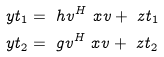Convert formula to latex. <formula><loc_0><loc_0><loc_500><loc_500>\ y t _ { 1 } & = \ h v ^ { H } \ x v + \ z t _ { 1 } \\ \ y t _ { 2 } & = \ g v ^ { H } \ x v + \ z t _ { 2 }</formula> 